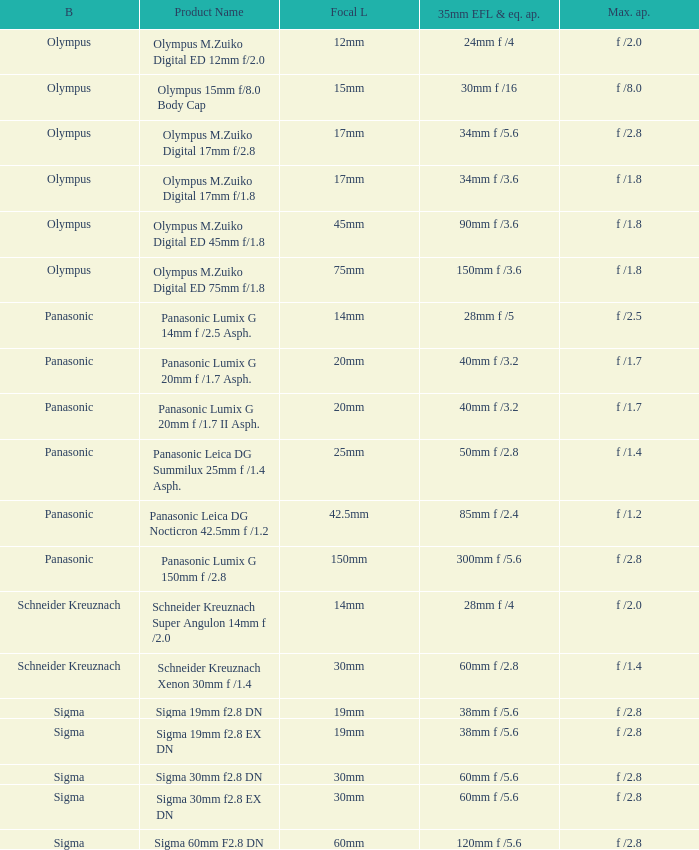What is the brand of the Sigma 30mm f2.8 DN, which has a maximum aperture of f /2.8 and a focal length of 30mm? Sigma. 